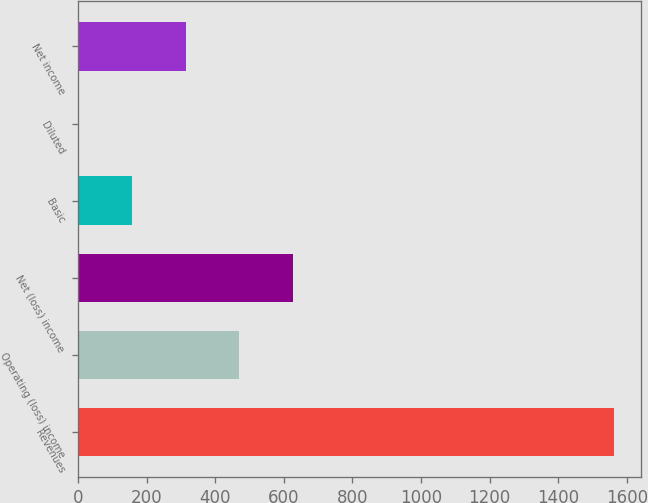Convert chart to OTSL. <chart><loc_0><loc_0><loc_500><loc_500><bar_chart><fcel>Revenues<fcel>Operating (loss) income<fcel>Net (loss) income<fcel>Basic<fcel>Diluted<fcel>Net income<nl><fcel>1563<fcel>469.96<fcel>626.11<fcel>157.66<fcel>1.51<fcel>313.81<nl></chart> 